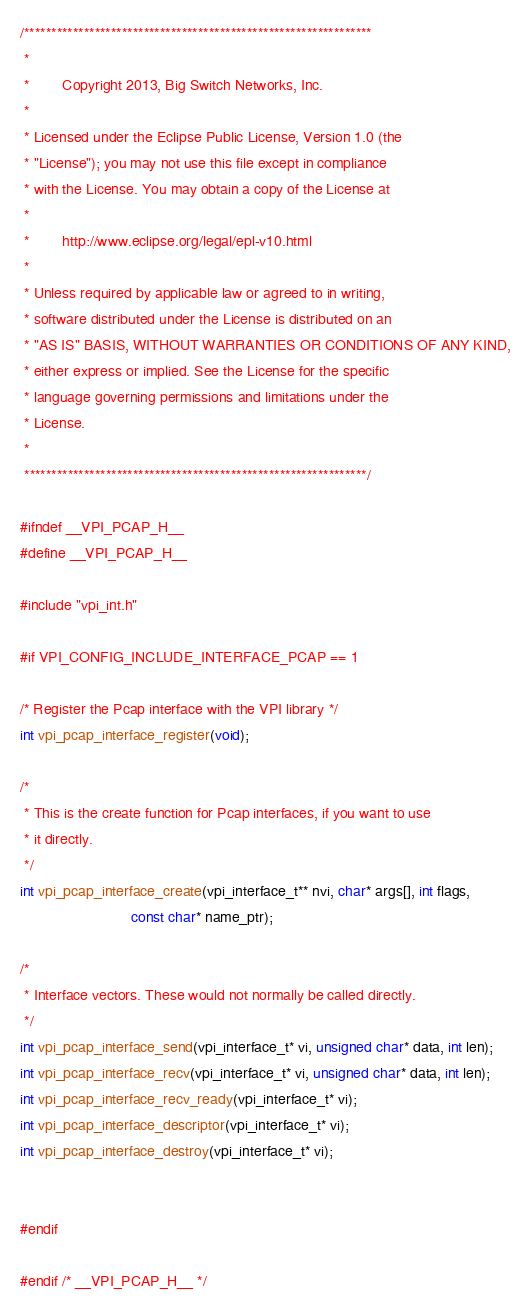Convert code to text. <code><loc_0><loc_0><loc_500><loc_500><_C_>/****************************************************************
 *
 *        Copyright 2013, Big Switch Networks, Inc.
 *
 * Licensed under the Eclipse Public License, Version 1.0 (the
 * "License"); you may not use this file except in compliance
 * with the License. You may obtain a copy of the License at
 *
 *        http://www.eclipse.org/legal/epl-v10.html
 *
 * Unless required by applicable law or agreed to in writing,
 * software distributed under the License is distributed on an
 * "AS IS" BASIS, WITHOUT WARRANTIES OR CONDITIONS OF ANY KIND,
 * either express or implied. See the License for the specific
 * language governing permissions and limitations under the
 * License.
 *
 ***************************************************************/

#ifndef __VPI_PCAP_H__
#define __VPI_PCAP_H__

#include "vpi_int.h"

#if VPI_CONFIG_INCLUDE_INTERFACE_PCAP == 1

/* Register the Pcap interface with the VPI library */
int vpi_pcap_interface_register(void);

/*
 * This is the create function for Pcap interfaces, if you want to use
 * it directly.
 */
int vpi_pcap_interface_create(vpi_interface_t** nvi, char* args[], int flags,
                           const char* name_ptr);

/*
 * Interface vectors. These would not normally be called directly.
 */
int vpi_pcap_interface_send(vpi_interface_t* vi, unsigned char* data, int len);
int vpi_pcap_interface_recv(vpi_interface_t* vi, unsigned char* data, int len);
int vpi_pcap_interface_recv_ready(vpi_interface_t* vi);
int vpi_pcap_interface_descriptor(vpi_interface_t* vi);
int vpi_pcap_interface_destroy(vpi_interface_t* vi);


#endif

#endif /* __VPI_PCAP_H__ */


</code> 